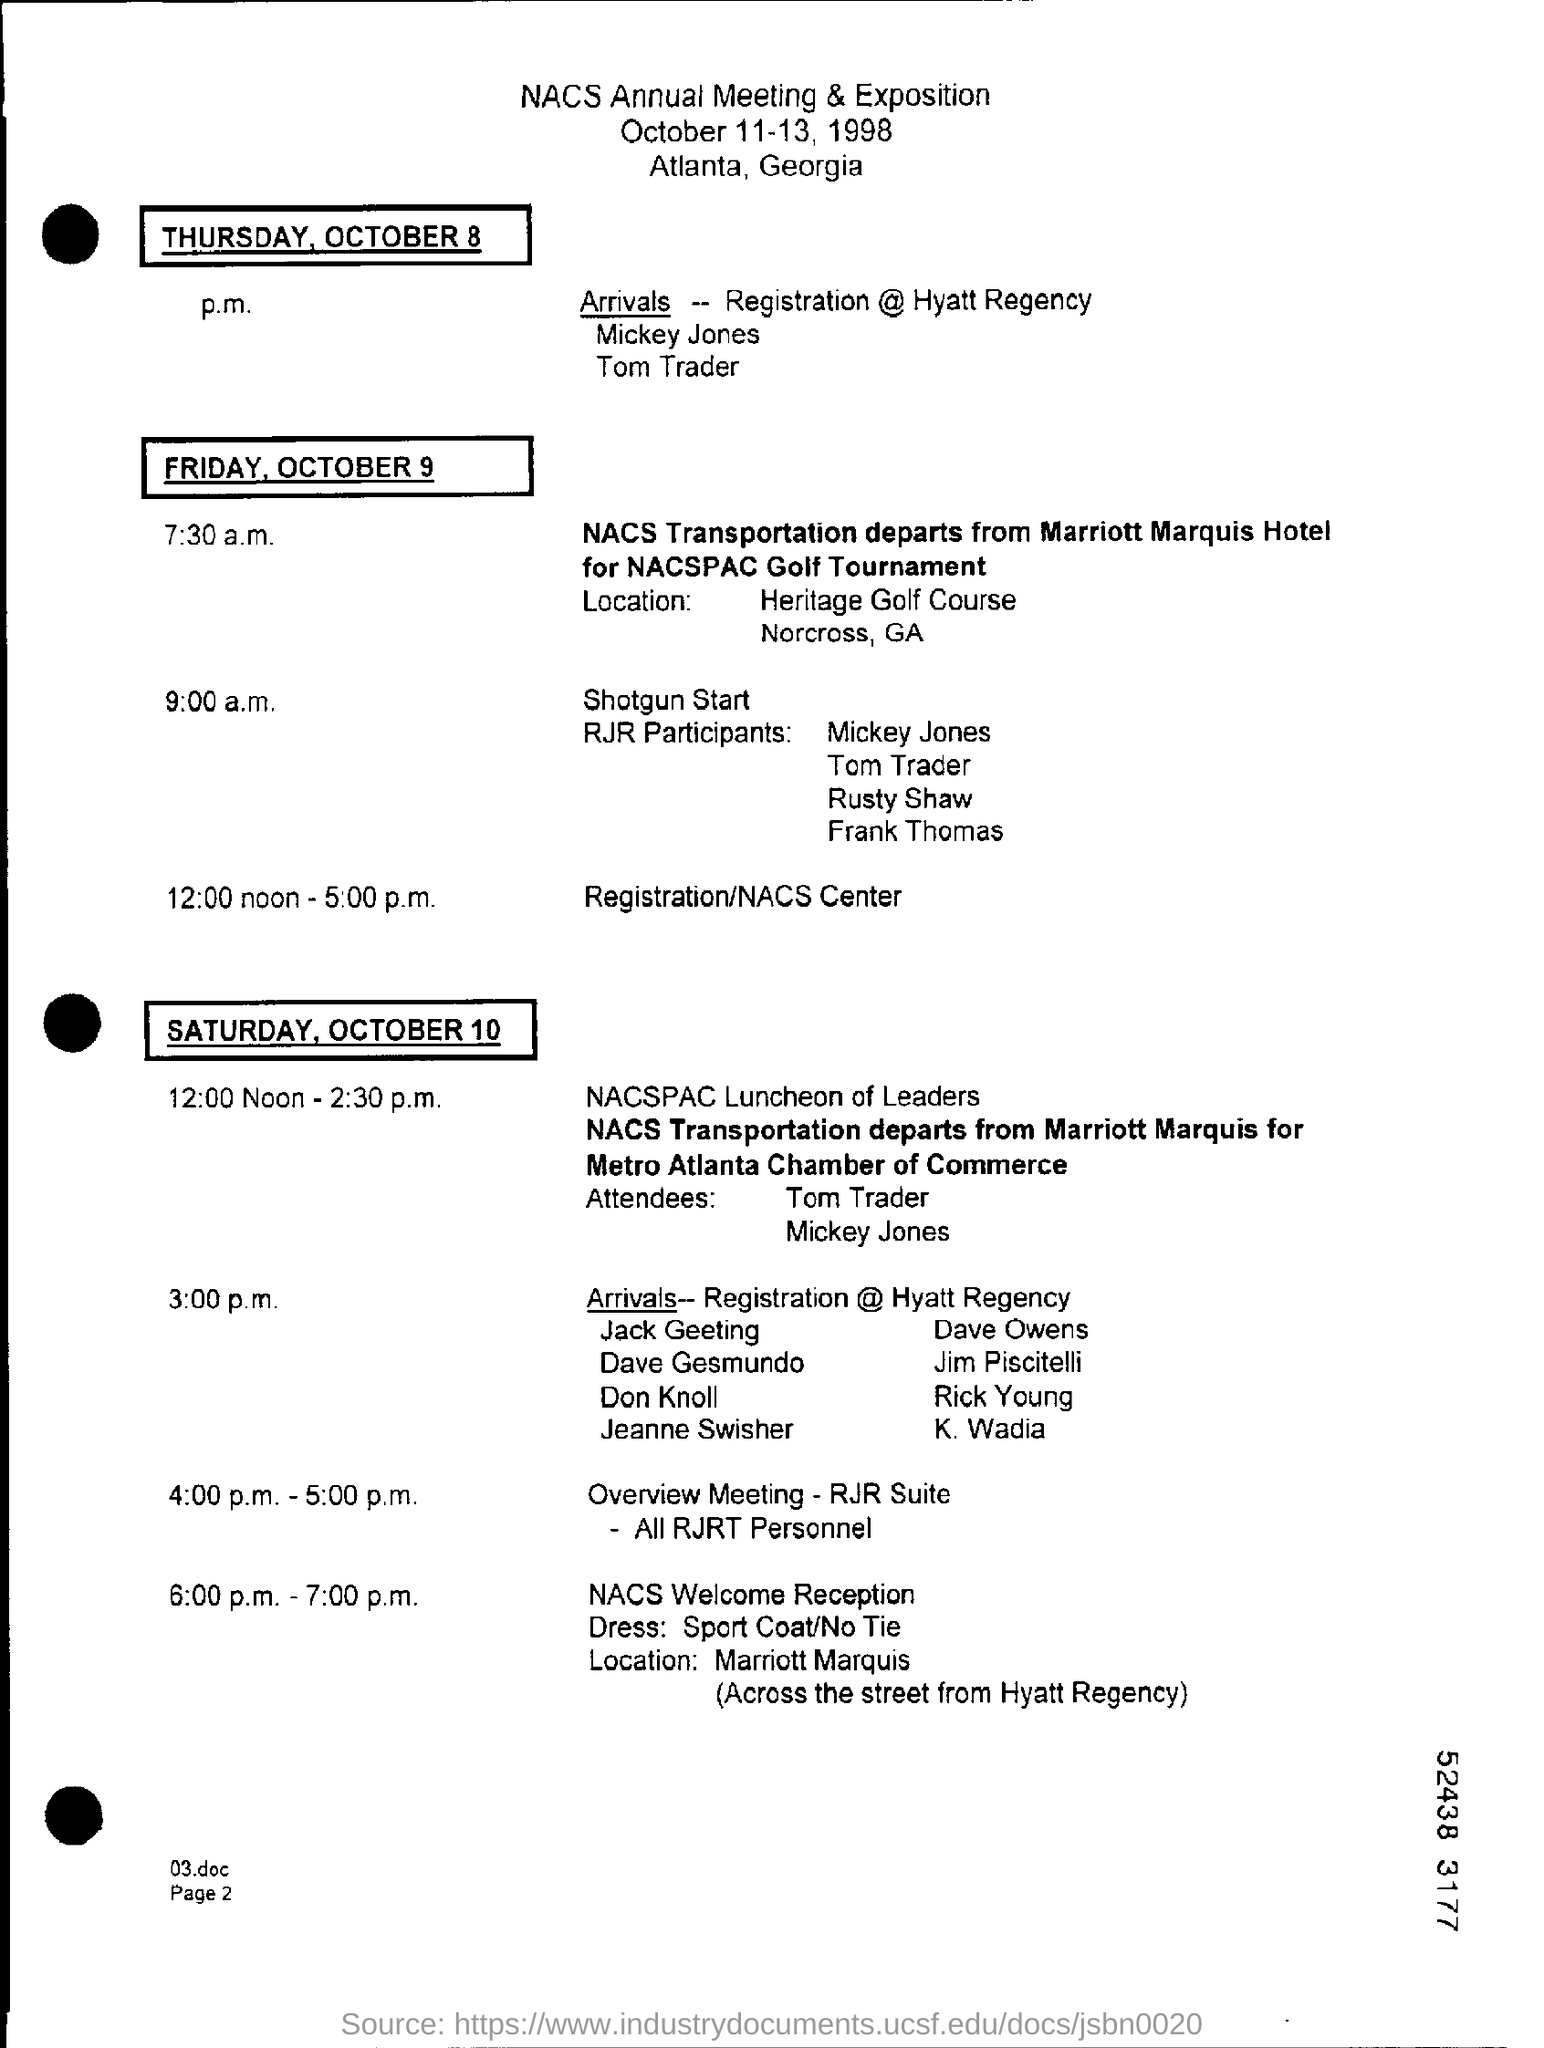List a handful of essential elements in this visual. The NACS Annual Meeting & Exposition will be held from October 11-13, 1998. The overview meeting of all RJRT personnel is scheduled to take place from 4:00 p.m. to 5:00 p.m. 